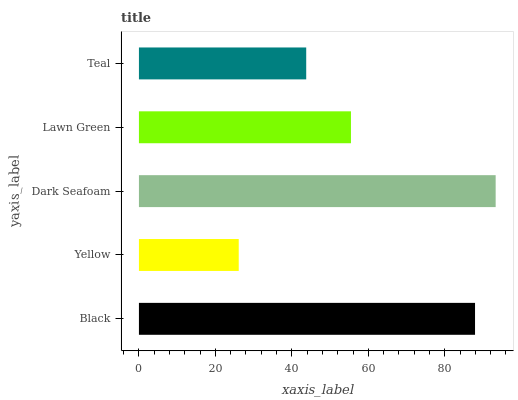Is Yellow the minimum?
Answer yes or no. Yes. Is Dark Seafoam the maximum?
Answer yes or no. Yes. Is Dark Seafoam the minimum?
Answer yes or no. No. Is Yellow the maximum?
Answer yes or no. No. Is Dark Seafoam greater than Yellow?
Answer yes or no. Yes. Is Yellow less than Dark Seafoam?
Answer yes or no. Yes. Is Yellow greater than Dark Seafoam?
Answer yes or no. No. Is Dark Seafoam less than Yellow?
Answer yes or no. No. Is Lawn Green the high median?
Answer yes or no. Yes. Is Lawn Green the low median?
Answer yes or no. Yes. Is Teal the high median?
Answer yes or no. No. Is Yellow the low median?
Answer yes or no. No. 